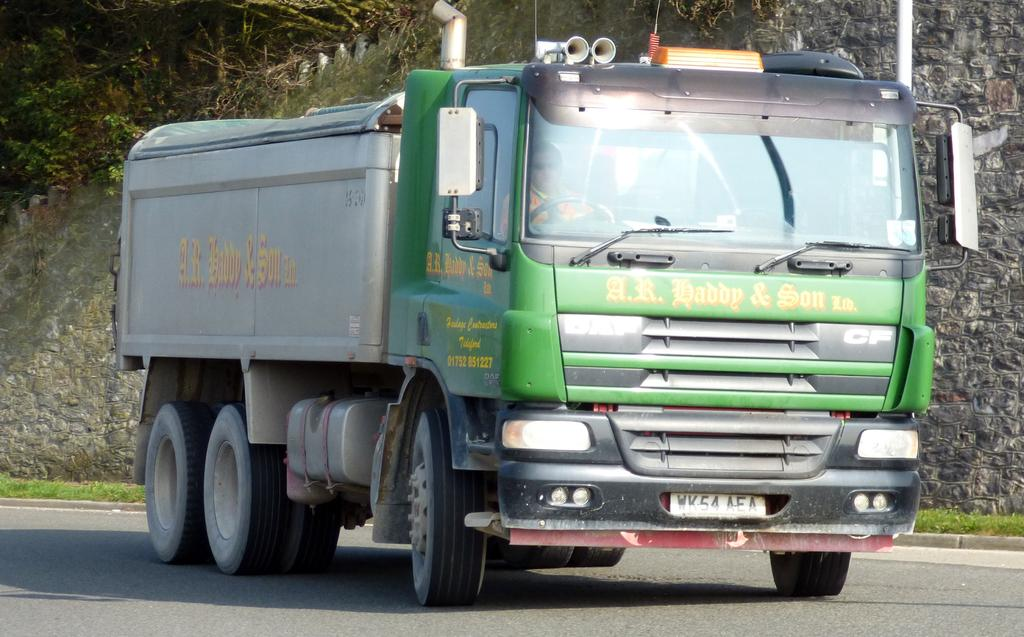What is the main subject in the foreground of the image? There is a truck in the foreground of the image. What can be seen in the background of the image? There is greenery in the background of the image. What type of cable is being used to decorate the cake in the image? There is no cake present in the image, and therefore no cable for decoration. 